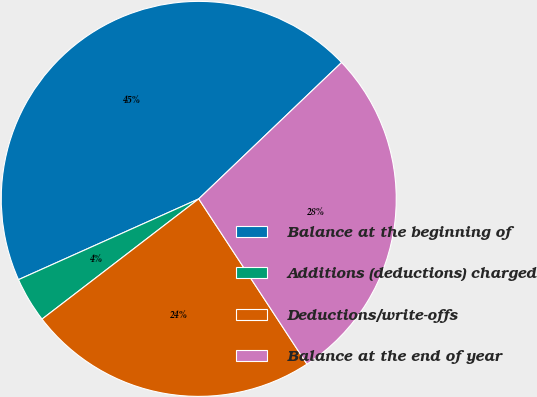Convert chart. <chart><loc_0><loc_0><loc_500><loc_500><pie_chart><fcel>Balance at the beginning of<fcel>Additions (deductions) charged<fcel>Deductions/write-offs<fcel>Balance at the end of year<nl><fcel>44.57%<fcel>3.71%<fcel>23.81%<fcel>27.9%<nl></chart> 